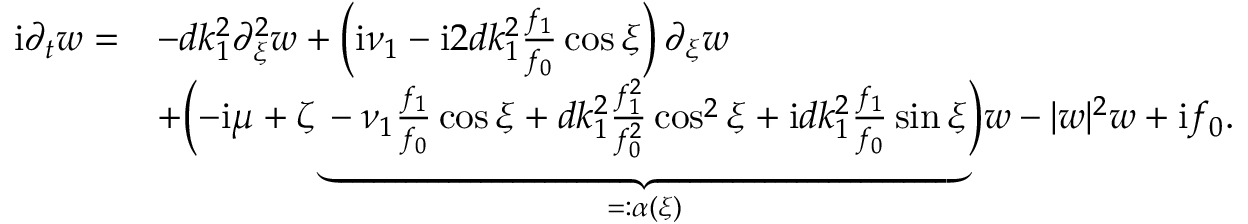<formula> <loc_0><loc_0><loc_500><loc_500>\begin{array} { r l } { i \partial _ { t } w = } & { - d k _ { 1 } ^ { 2 } \partial _ { \xi } ^ { 2 } w + \left ( i \nu _ { 1 } - i 2 d k _ { 1 } ^ { 2 } \frac { f _ { 1 } } { f _ { 0 } } \cos \xi \right ) \partial _ { \xi } w } \\ & { + \left ( - i \mu + \zeta \underbrace { - \nu _ { 1 } \frac { f _ { 1 } } { f _ { 0 } } \cos \xi + d k _ { 1 } ^ { 2 } \frac { f _ { 1 } ^ { 2 } } { f _ { 0 } ^ { 2 } } \cos ^ { 2 } \xi + i d k _ { 1 } ^ { 2 } \frac { f _ { 1 } } { f _ { 0 } } \sin \xi } _ { = \colon \alpha ( \xi ) } \right ) w - | w | ^ { 2 } w + i f _ { 0 } . } \end{array}</formula> 